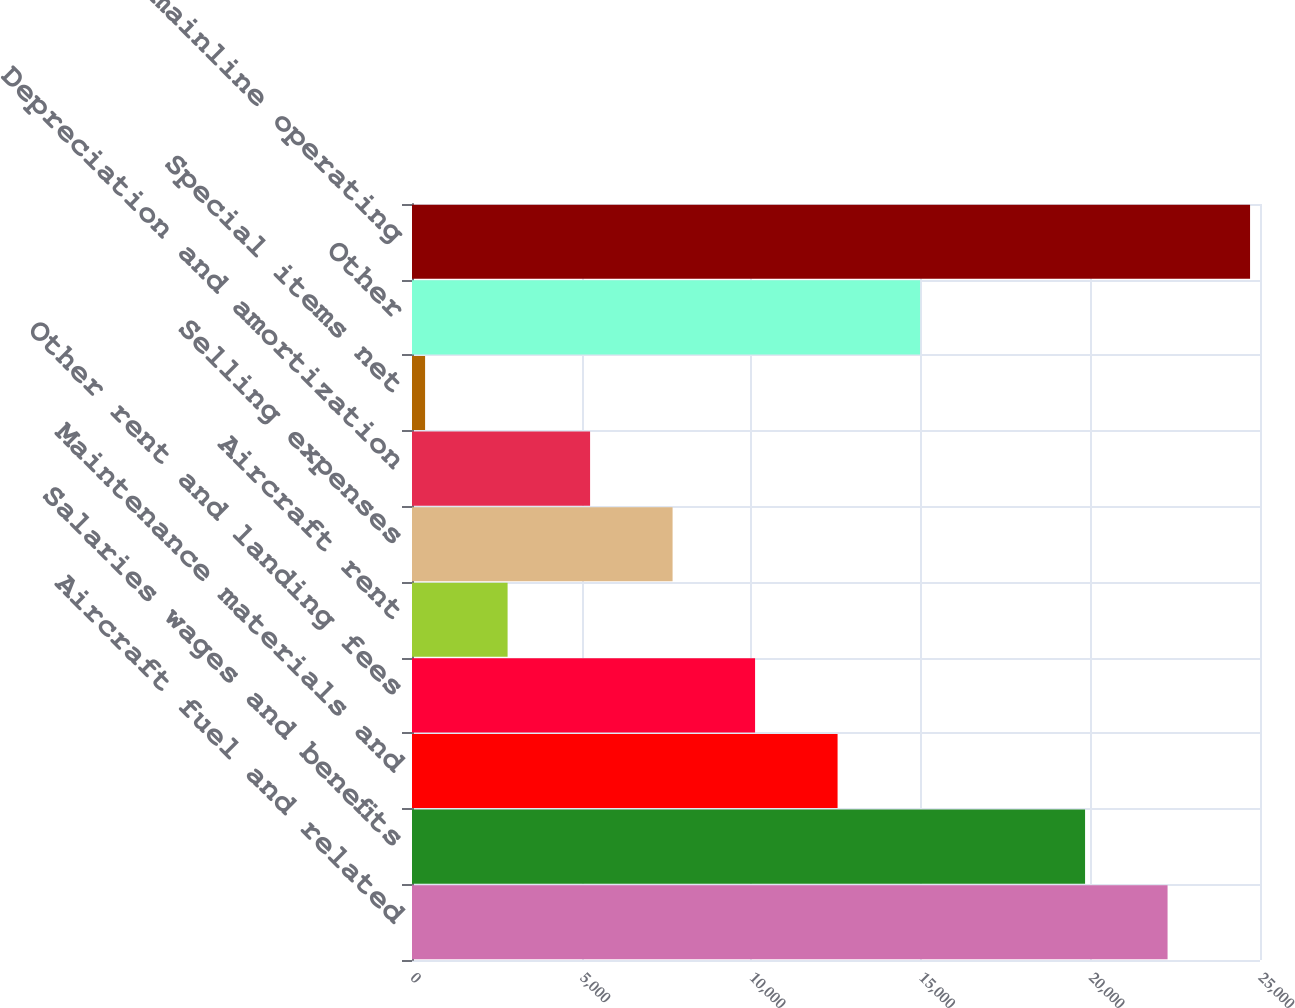Convert chart to OTSL. <chart><loc_0><loc_0><loc_500><loc_500><bar_chart><fcel>Aircraft fuel and related<fcel>Salaries wages and benefits<fcel>Maintenance materials and<fcel>Other rent and landing fees<fcel>Aircraft rent<fcel>Selling expenses<fcel>Depreciation and amortization<fcel>Special items net<fcel>Other<fcel>Total mainline operating<nl><fcel>22274.9<fcel>19842.8<fcel>12546.5<fcel>10114.4<fcel>2818.1<fcel>7682.3<fcel>5250.2<fcel>386<fcel>14978.6<fcel>24707<nl></chart> 